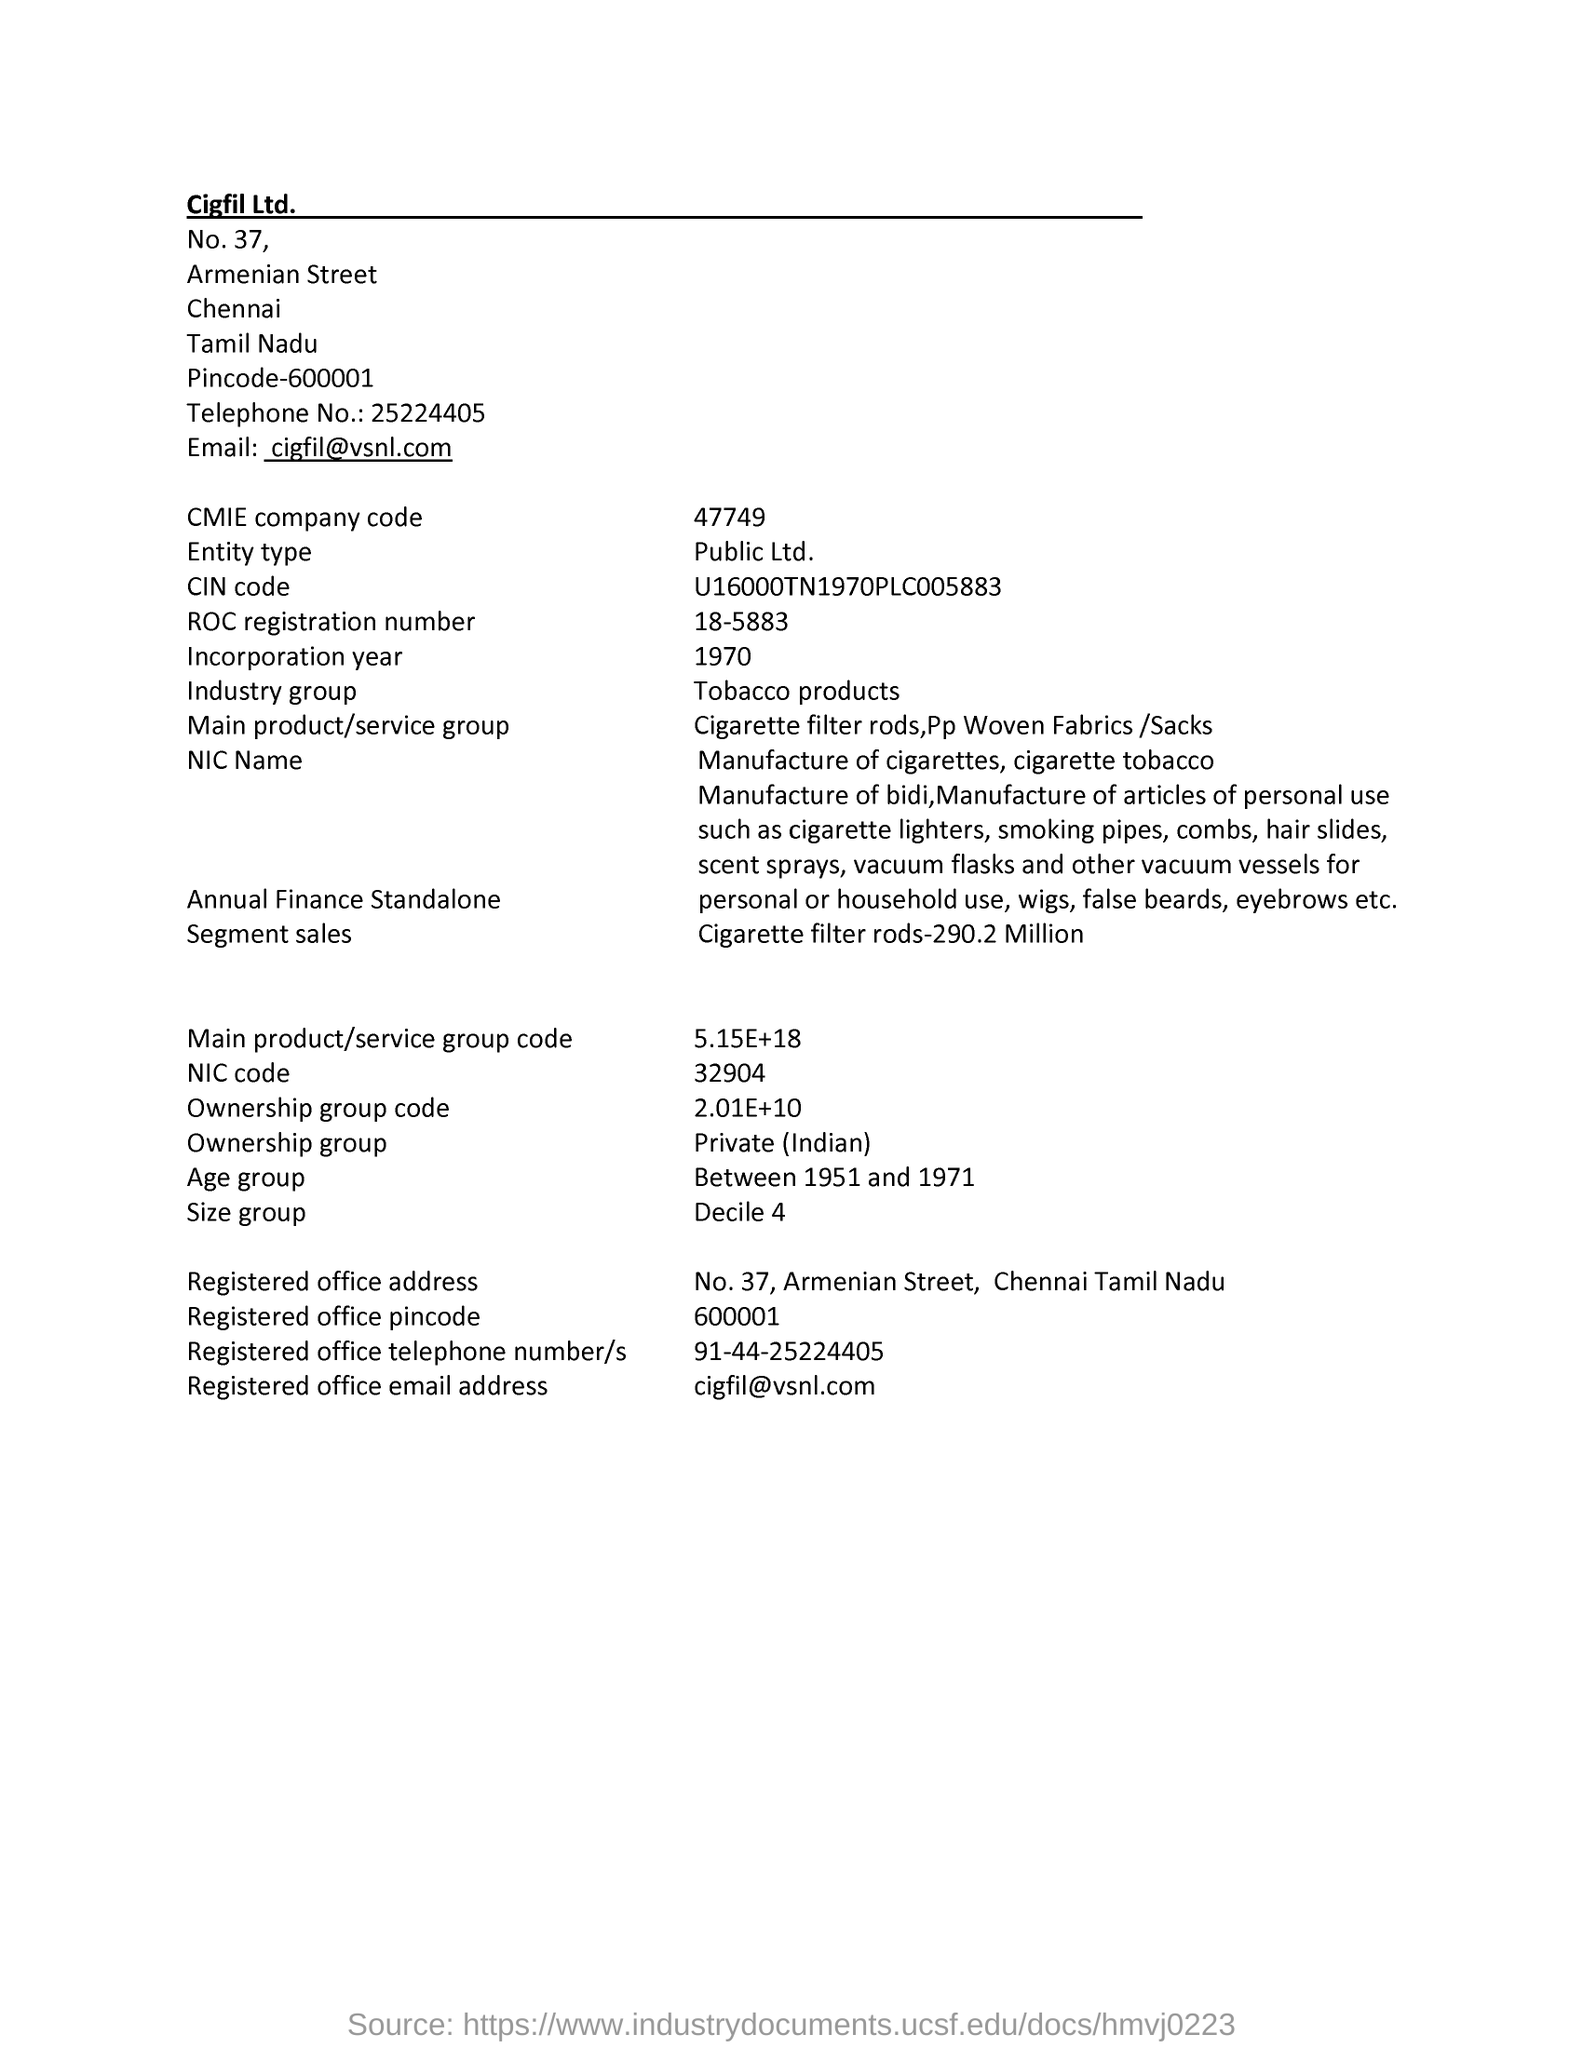What is the CMIE company code given
Offer a very short reply. 47749. What is the company Entity type given in this page
Provide a succinct answer. Public ltd. What is the Age Group given in this document
Give a very brief answer. Between 1951 and 1971. What is the Registered office email address of company
Keep it short and to the point. Cigfil@vsnl.com. 